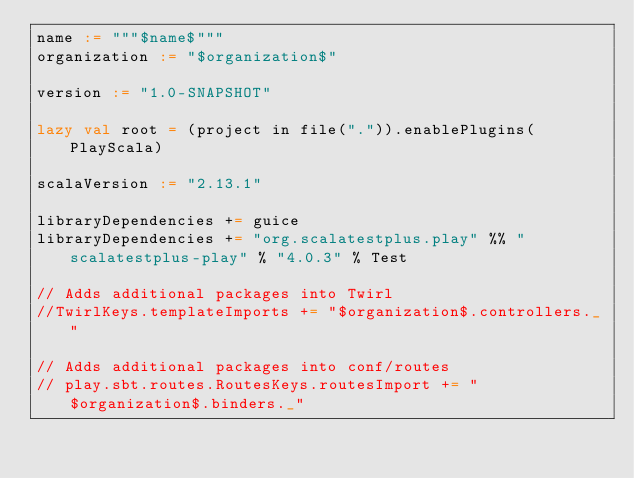<code> <loc_0><loc_0><loc_500><loc_500><_Scala_>name := """$name$"""
organization := "$organization$"

version := "1.0-SNAPSHOT"

lazy val root = (project in file(".")).enablePlugins(PlayScala)

scalaVersion := "2.13.1"

libraryDependencies += guice
libraryDependencies += "org.scalatestplus.play" %% "scalatestplus-play" % "4.0.3" % Test

// Adds additional packages into Twirl
//TwirlKeys.templateImports += "$organization$.controllers._"

// Adds additional packages into conf/routes
// play.sbt.routes.RoutesKeys.routesImport += "$organization$.binders._"
</code> 